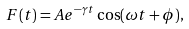Convert formula to latex. <formula><loc_0><loc_0><loc_500><loc_500>F ( t ) = A { e } ^ { - \gamma t } \cos ( \omega t + \phi ) ,</formula> 